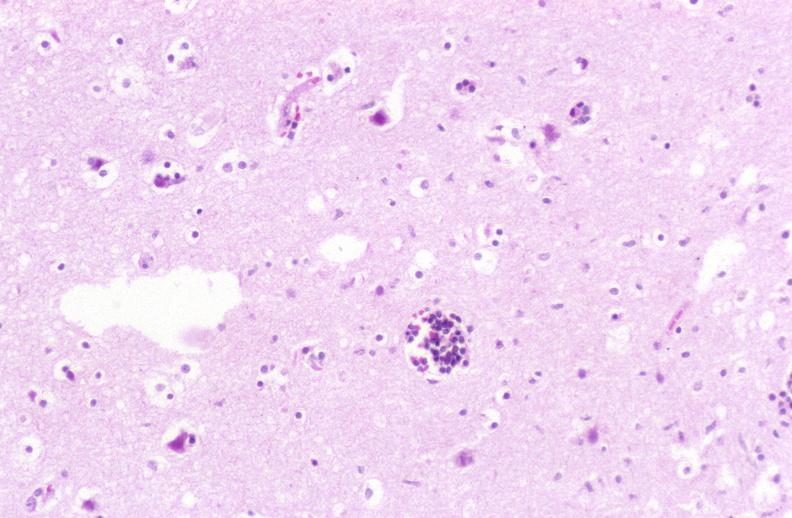what is present?
Answer the question using a single word or phrase. Nervous 